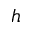<formula> <loc_0><loc_0><loc_500><loc_500>h</formula> 